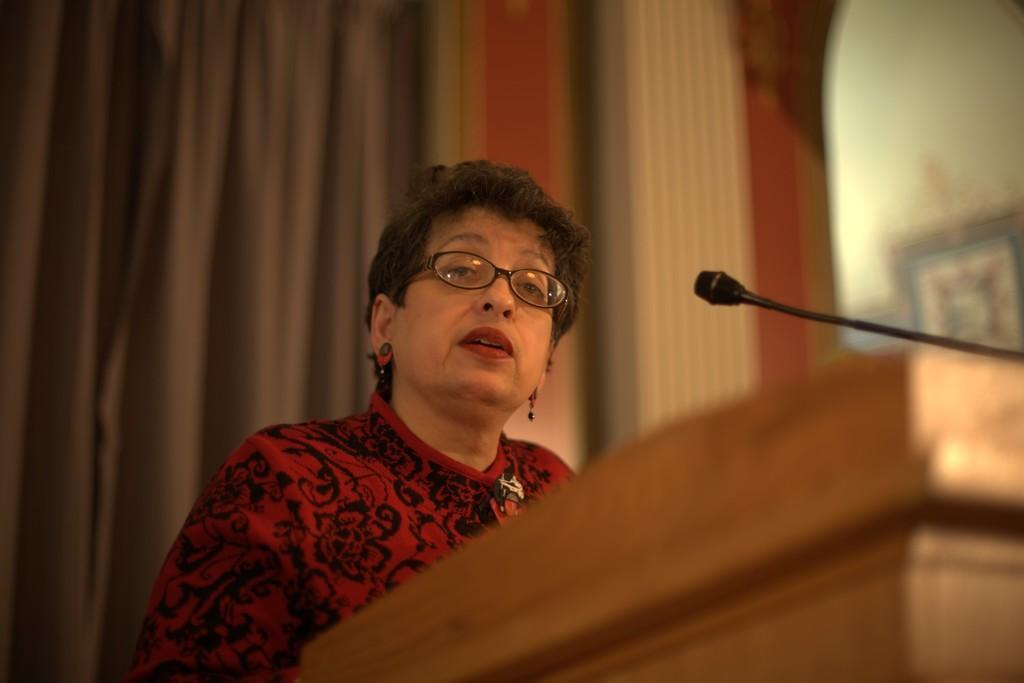In one or two sentences, can you explain what this image depicts? In this image we can see a woman. She is wearing a red and black color dress. In front of her, we can see a podium and a mic. In the background, we can see a curtain, wall and a frame. 